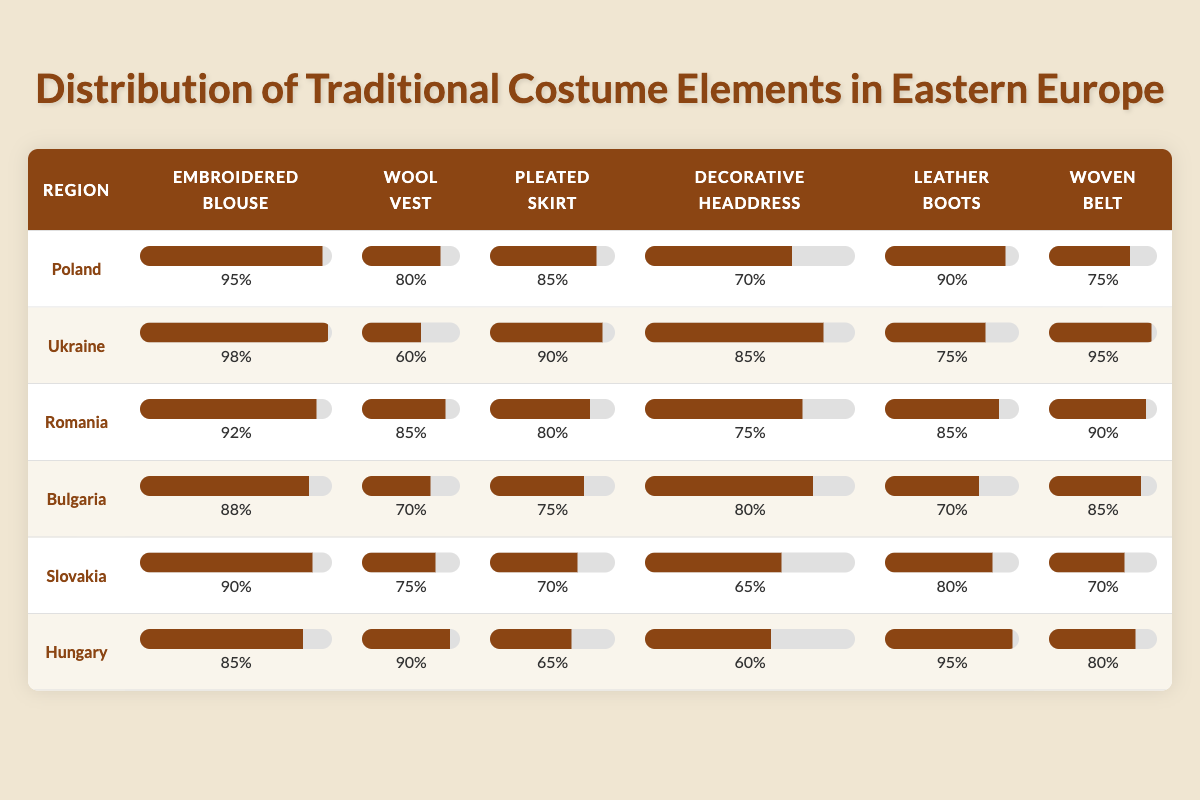What percentage of regions have "Decorative headdress" over 75%? Looking at the table, "Decorative headdress" has values over 75% in Poland (70%), Ukraine (85%), Romania (75%), Bulgaria (80%), Slovakia (65%), and Hungary (60%). Only Ukraine and Romania meet this requirement, making it a total of 2 regions out of 6, or 33.33%.
Answer: 33.33% Which region has the highest percentage for "Woven belt"? By reviewing the table, Ukraine has the highest percentage for "Woven belt" at 95%.
Answer: Ukraine If we add the percentages of "Pleated skirt" for all regions, what is the total? Adding the percentages for "Pleated skirt": Poland (85) + Ukraine (90) + Romania (80) + Bulgaria (75) + Slovakia (70) + Hungary (65) gives us a total of 465.
Answer: 465 Is the percentage of "Embroidered blouse" in Hungary greater than the percentage of "Leather boots" in Romania? Checking the values, Hungary has 85% for "Embroidered blouse" and Romania has 85% for "Leather boots". Since these values are equal, the answer is no.
Answer: No What is the average percentage for "Wool vest" across all regions? Adding the percentages for "Wool vest": Poland (80) + Ukraine (60) + Romania (85) + Bulgaria (70) + Slovakia (75) + Hungary (90) gives us 460. Dividing by the number of regions (6) gives us an average of 76.67.
Answer: 76.67 